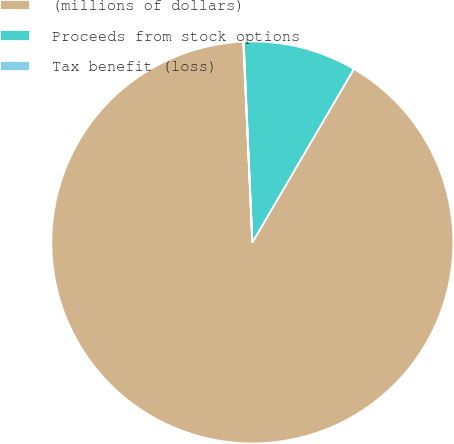Convert chart to OTSL. <chart><loc_0><loc_0><loc_500><loc_500><pie_chart><fcel>(millions of dollars)<fcel>Proceeds from stock options<fcel>Tax benefit (loss)<nl><fcel>90.85%<fcel>9.11%<fcel>0.03%<nl></chart> 